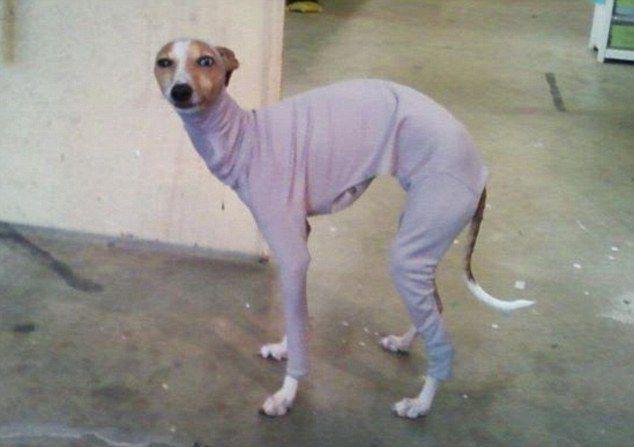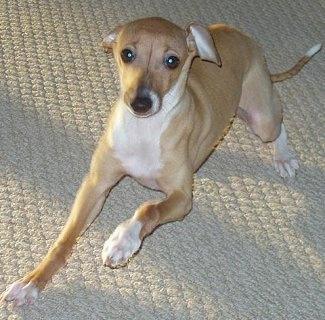The first image is the image on the left, the second image is the image on the right. Given the left and right images, does the statement "Left image contains two standing dogs, and right image contains one non-standing dog." hold true? Answer yes or no. No. The first image is the image on the left, the second image is the image on the right. Examine the images to the left and right. Is the description "There are three dogs shown." accurate? Answer yes or no. No. 